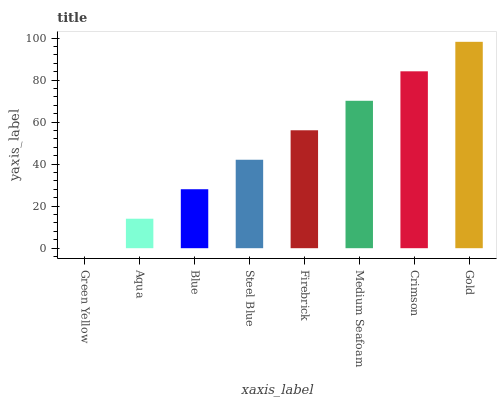Is Green Yellow the minimum?
Answer yes or no. Yes. Is Gold the maximum?
Answer yes or no. Yes. Is Aqua the minimum?
Answer yes or no. No. Is Aqua the maximum?
Answer yes or no. No. Is Aqua greater than Green Yellow?
Answer yes or no. Yes. Is Green Yellow less than Aqua?
Answer yes or no. Yes. Is Green Yellow greater than Aqua?
Answer yes or no. No. Is Aqua less than Green Yellow?
Answer yes or no. No. Is Firebrick the high median?
Answer yes or no. Yes. Is Steel Blue the low median?
Answer yes or no. Yes. Is Green Yellow the high median?
Answer yes or no. No. Is Blue the low median?
Answer yes or no. No. 